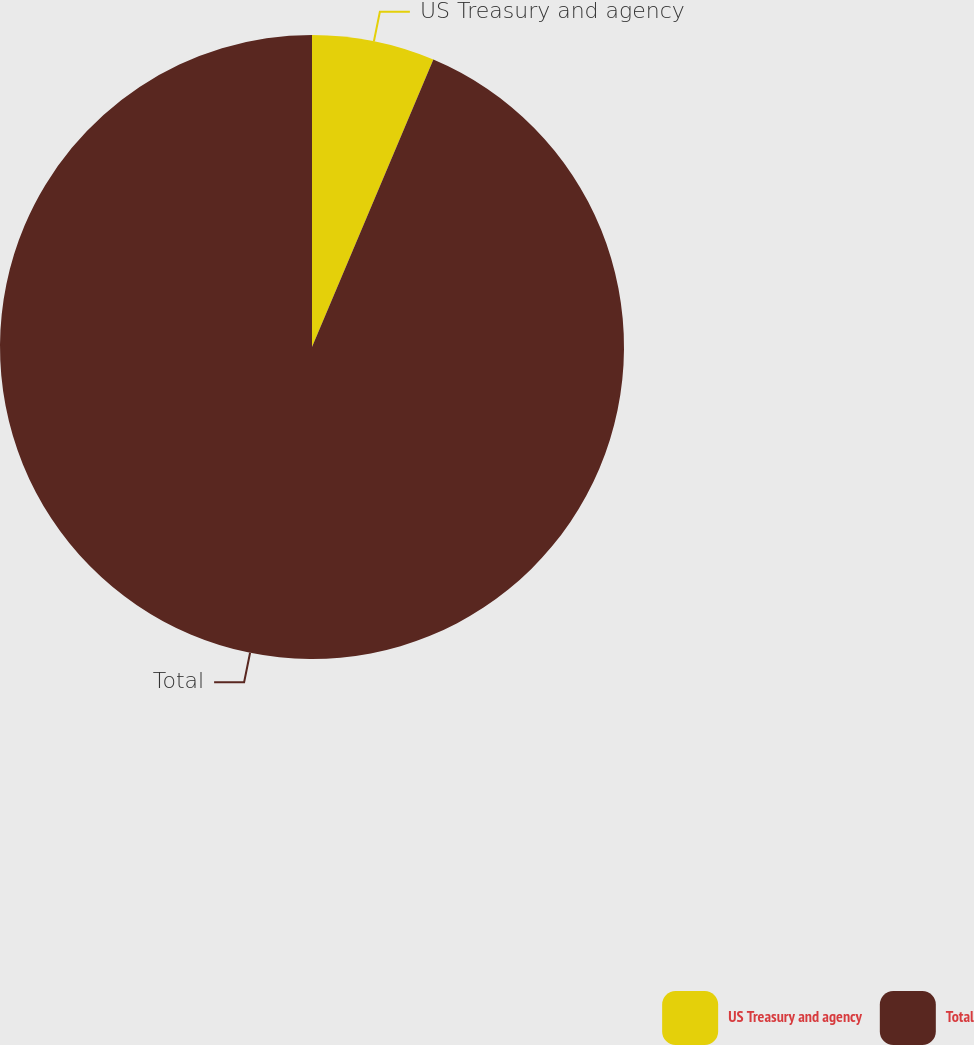<chart> <loc_0><loc_0><loc_500><loc_500><pie_chart><fcel>US Treasury and agency<fcel>Total<nl><fcel>6.36%<fcel>93.64%<nl></chart> 